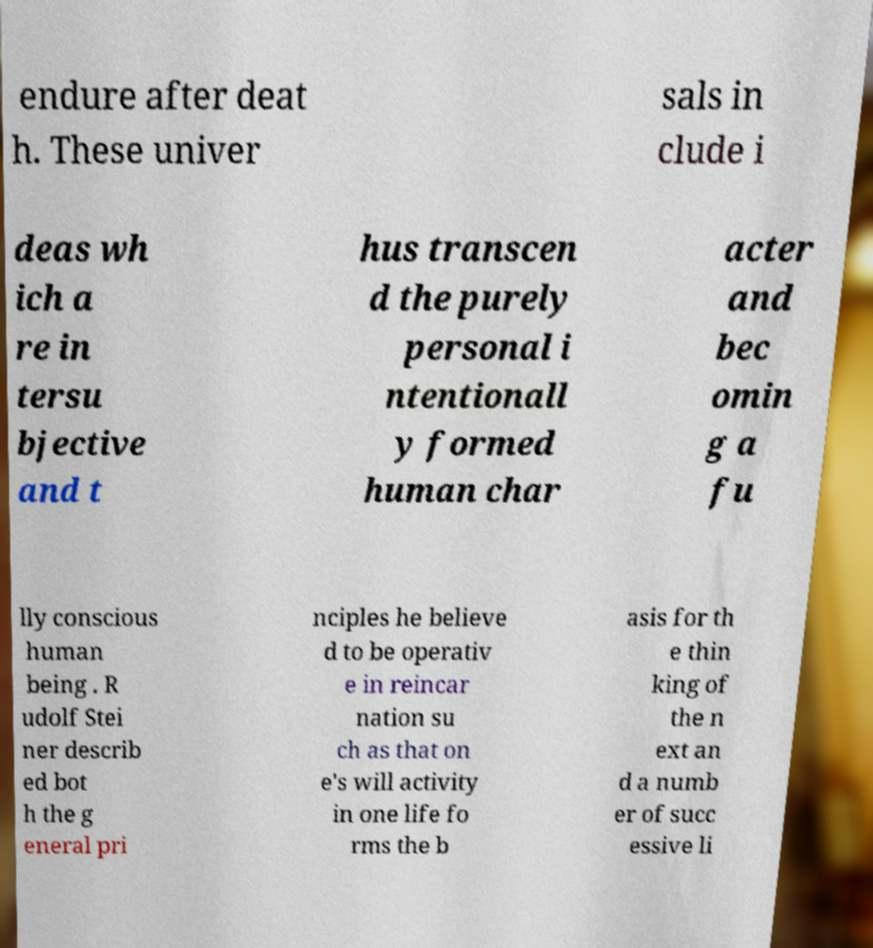Can you accurately transcribe the text from the provided image for me? endure after deat h. These univer sals in clude i deas wh ich a re in tersu bjective and t hus transcen d the purely personal i ntentionall y formed human char acter and bec omin g a fu lly conscious human being . R udolf Stei ner describ ed bot h the g eneral pri nciples he believe d to be operativ e in reincar nation su ch as that on e's will activity in one life fo rms the b asis for th e thin king of the n ext an d a numb er of succ essive li 